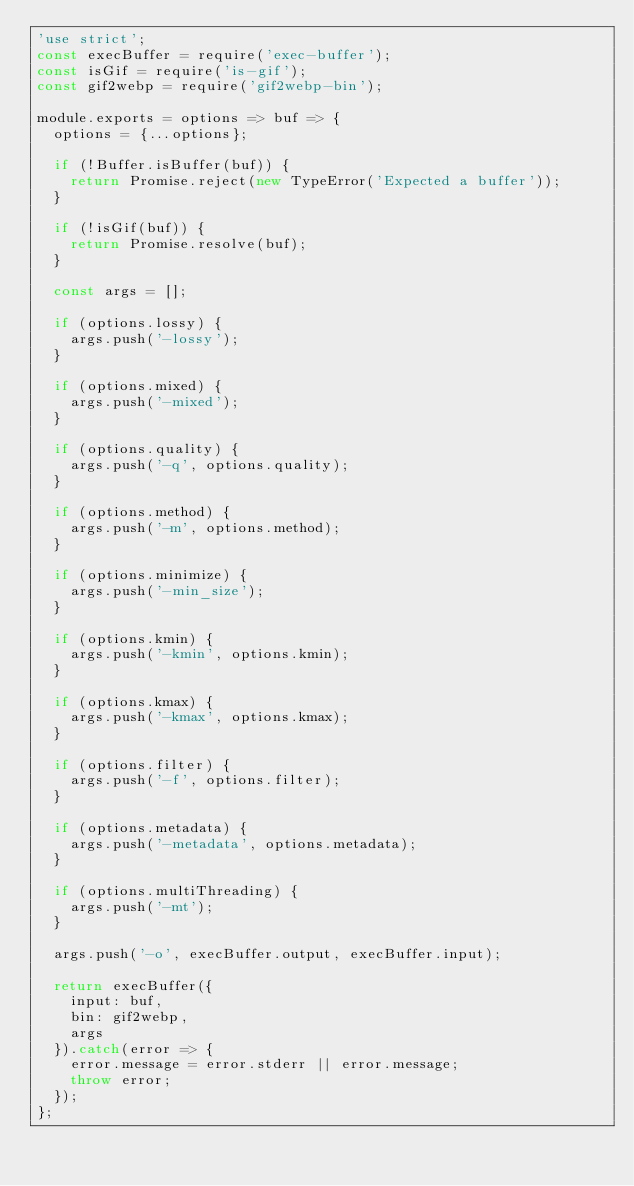Convert code to text. <code><loc_0><loc_0><loc_500><loc_500><_JavaScript_>'use strict';
const execBuffer = require('exec-buffer');
const isGif = require('is-gif');
const gif2webp = require('gif2webp-bin');

module.exports = options => buf => {
	options = {...options};

	if (!Buffer.isBuffer(buf)) {
		return Promise.reject(new TypeError('Expected a buffer'));
	}

	if (!isGif(buf)) {
		return Promise.resolve(buf);
	}

	const args = [];

	if (options.lossy) {
		args.push('-lossy');
	}

	if (options.mixed) {
		args.push('-mixed');
	}

	if (options.quality) {
		args.push('-q', options.quality);
	}

	if (options.method) {
		args.push('-m', options.method);
	}

	if (options.minimize) {
		args.push('-min_size');
	}

	if (options.kmin) {
		args.push('-kmin', options.kmin);
	}

	if (options.kmax) {
		args.push('-kmax', options.kmax);
	}

	if (options.filter) {
		args.push('-f', options.filter);
	}

	if (options.metadata) {
		args.push('-metadata', options.metadata);
	}

	if (options.multiThreading) {
		args.push('-mt');
	}

	args.push('-o', execBuffer.output, execBuffer.input);

	return execBuffer({
		input: buf,
		bin: gif2webp,
		args
	}).catch(error => {
		error.message = error.stderr || error.message;
		throw error;
	});
};
</code> 